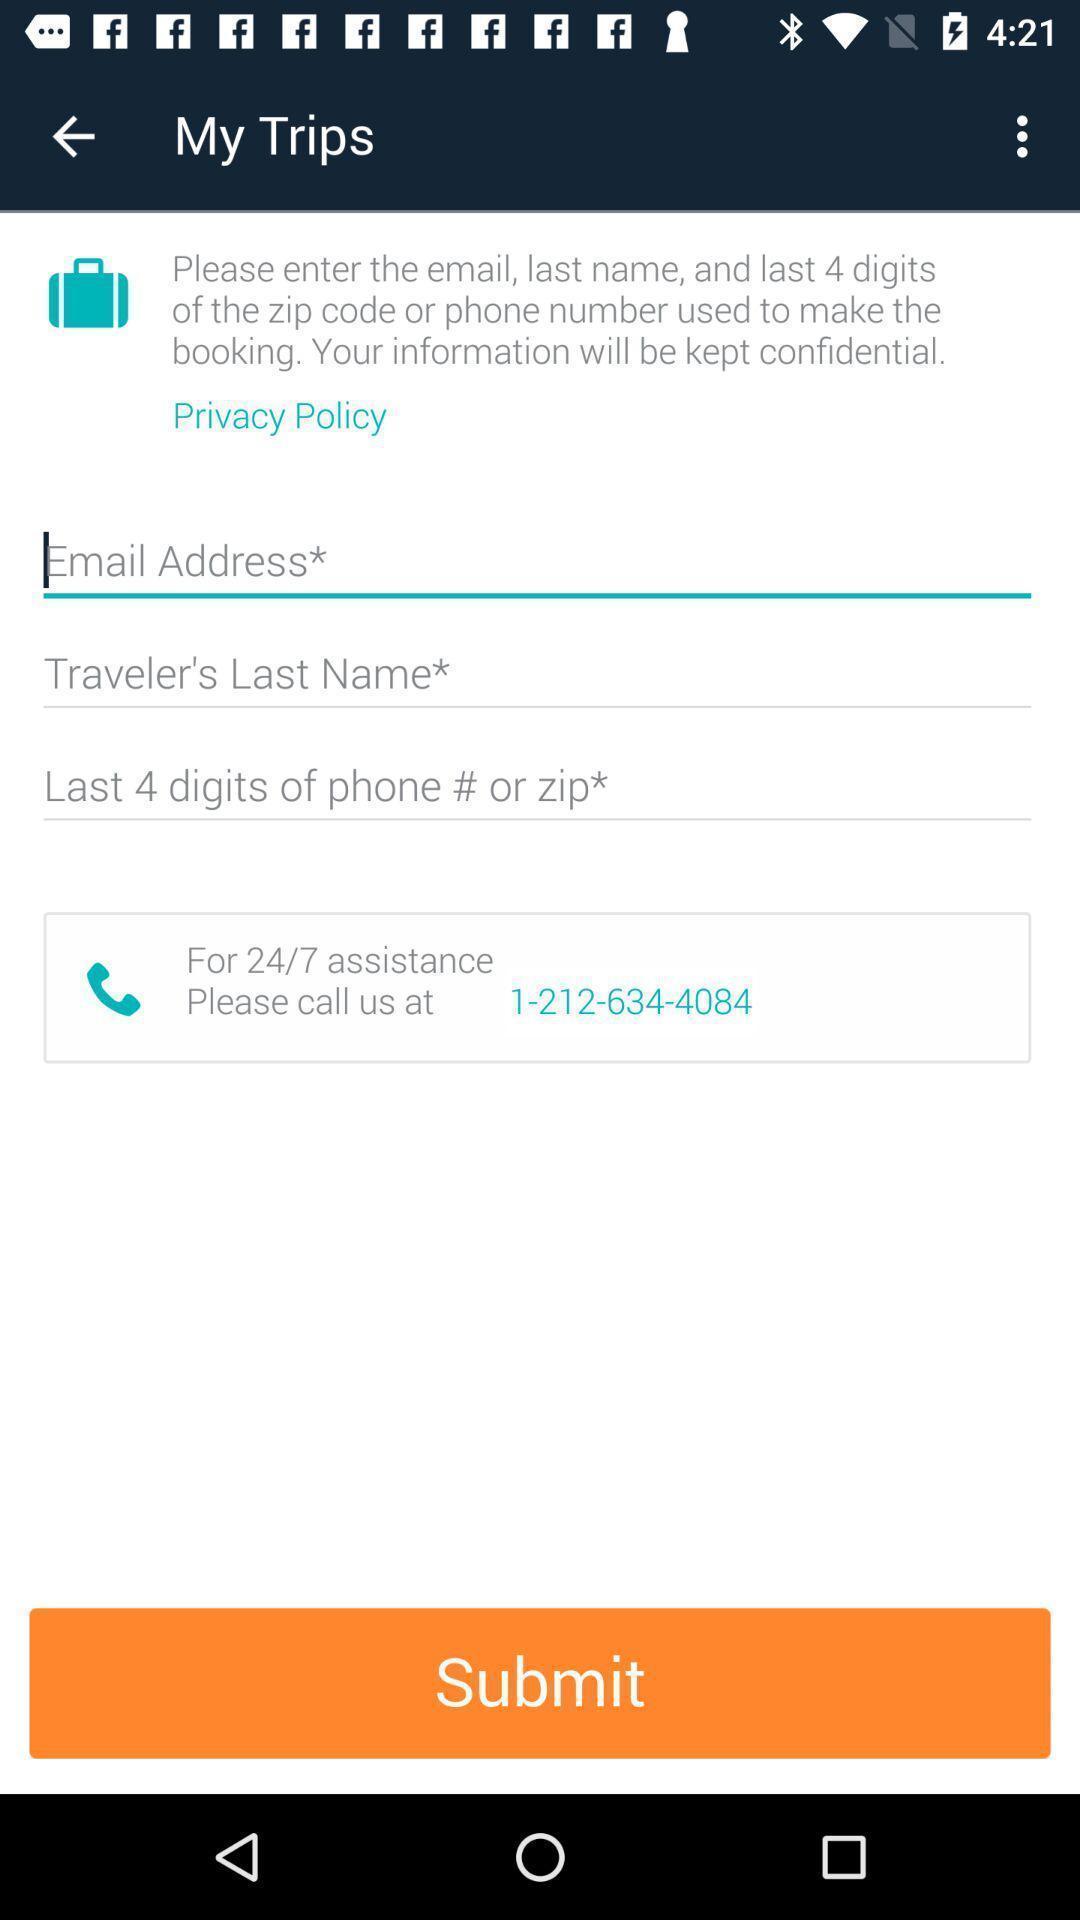Summarize the information in this screenshot. Screen displaying trip contents in a booking application. 